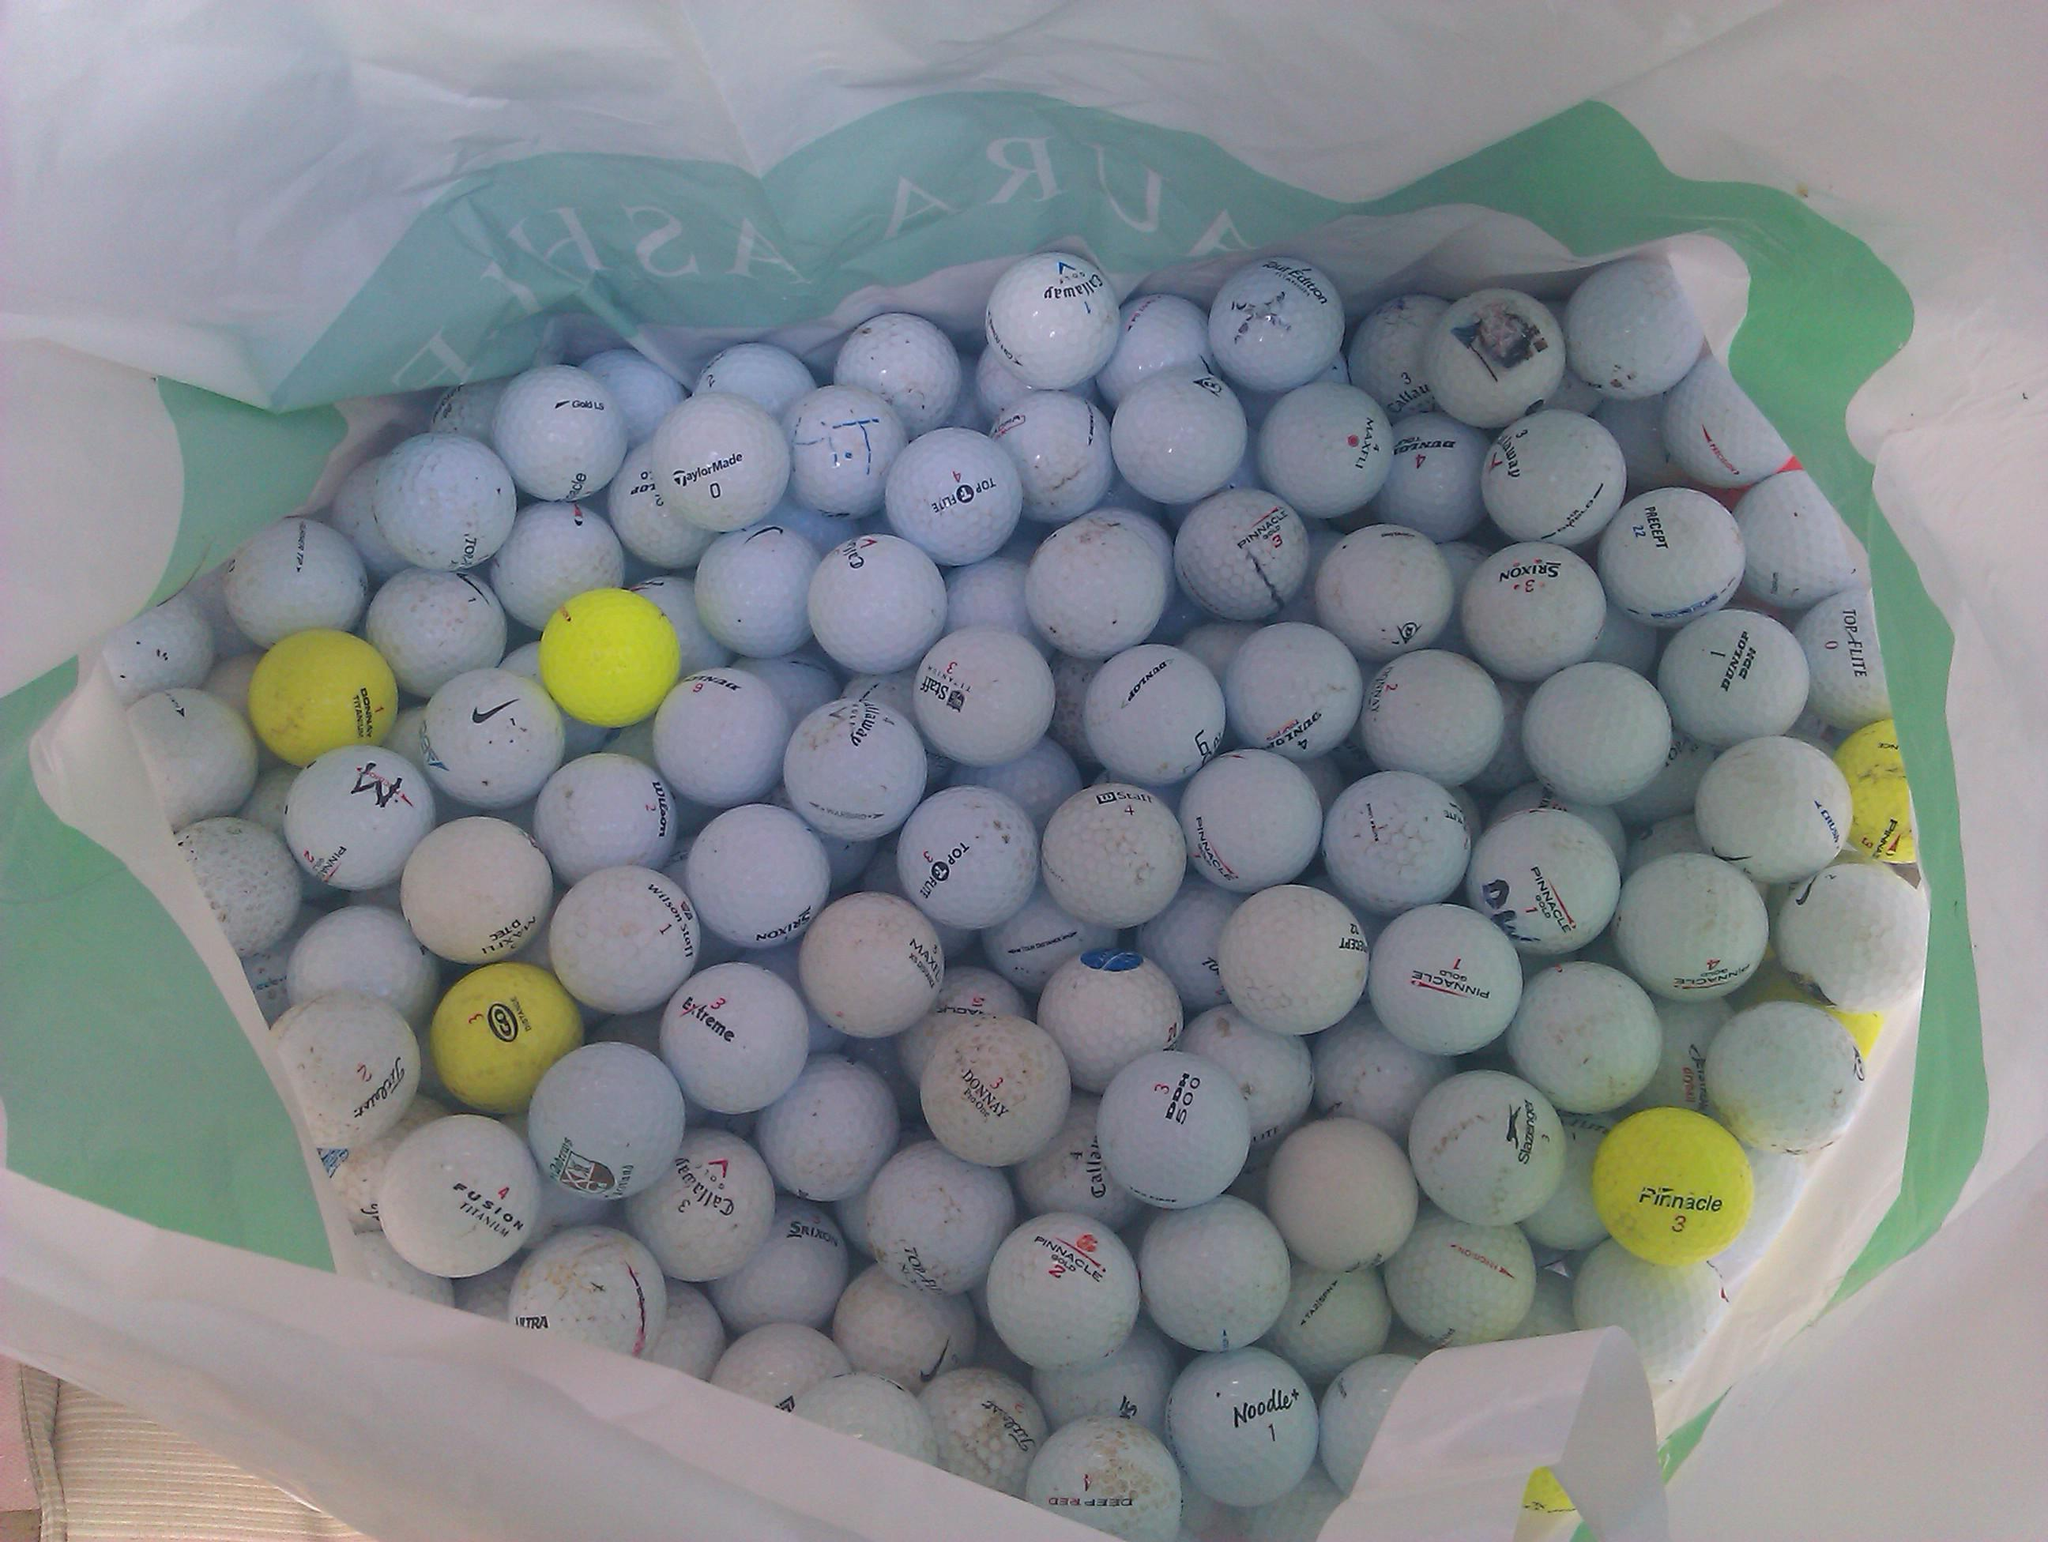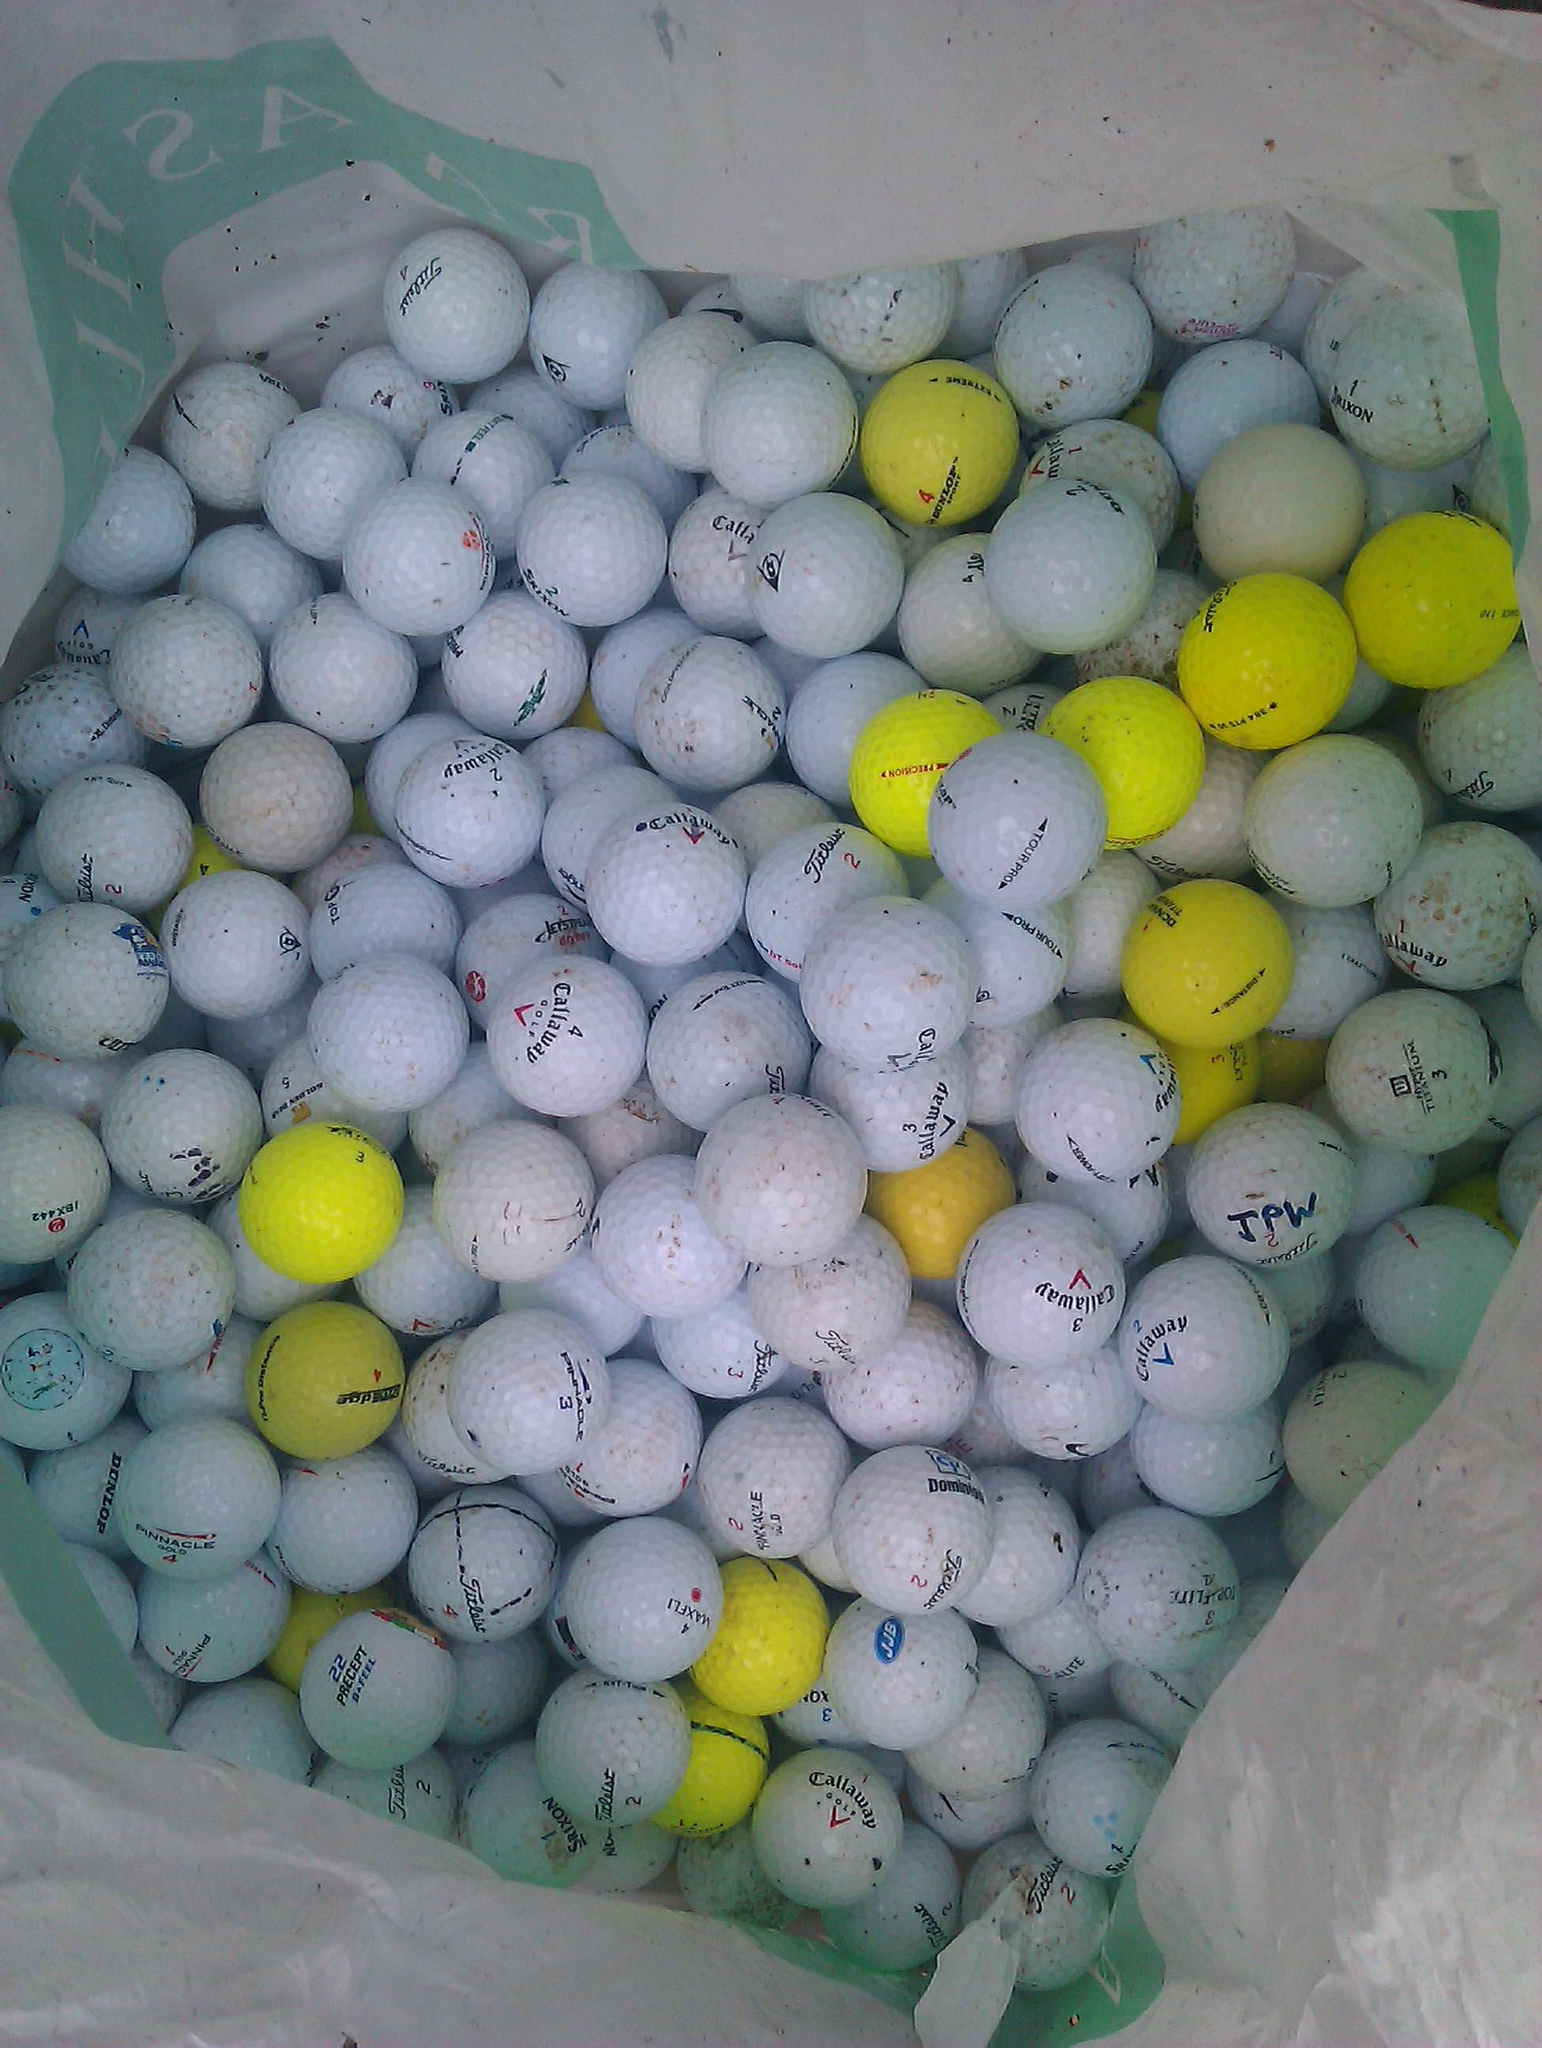The first image is the image on the left, the second image is the image on the right. Considering the images on both sides, is "A collection of golf balls includes at least one bright orange ball, in one image." valid? Answer yes or no. No. 